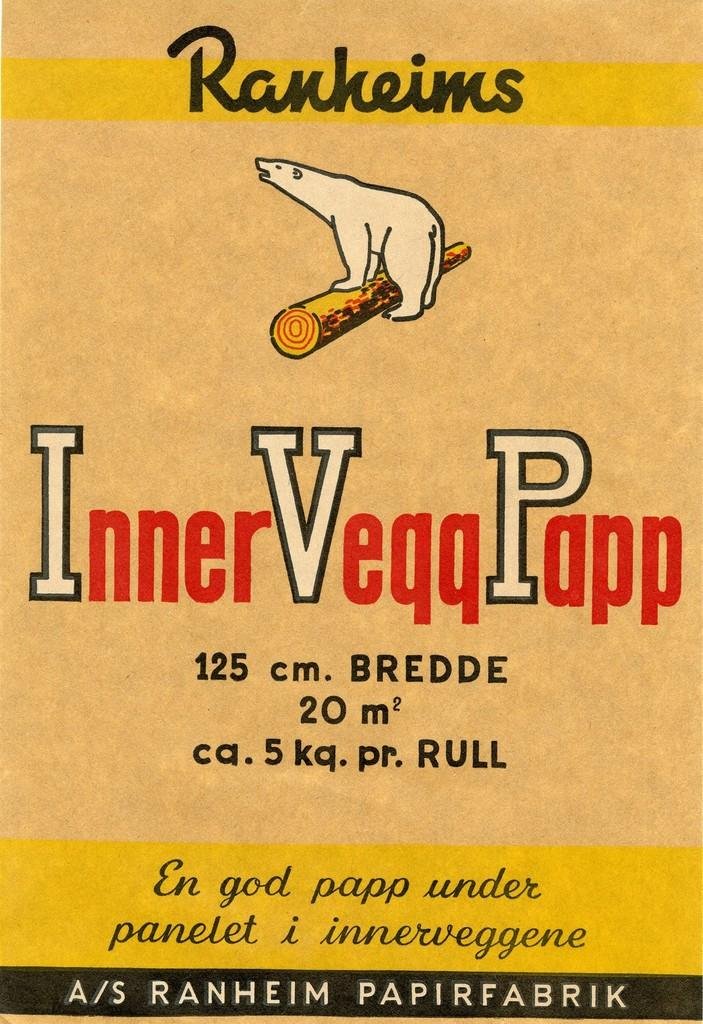<image>
Render a clear and concise summary of the photo. Poster for Ranheims showing a polar bear rolling a log. 